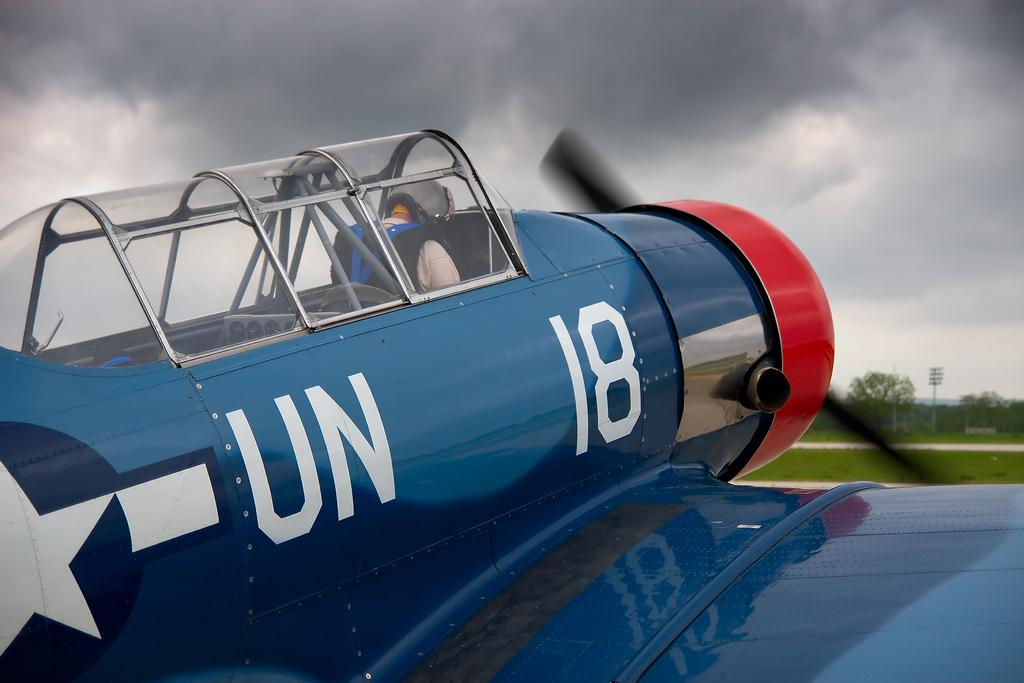<image>
Share a concise interpretation of the image provided. A blue air plane with Un eighteen emblazoned on the side. 